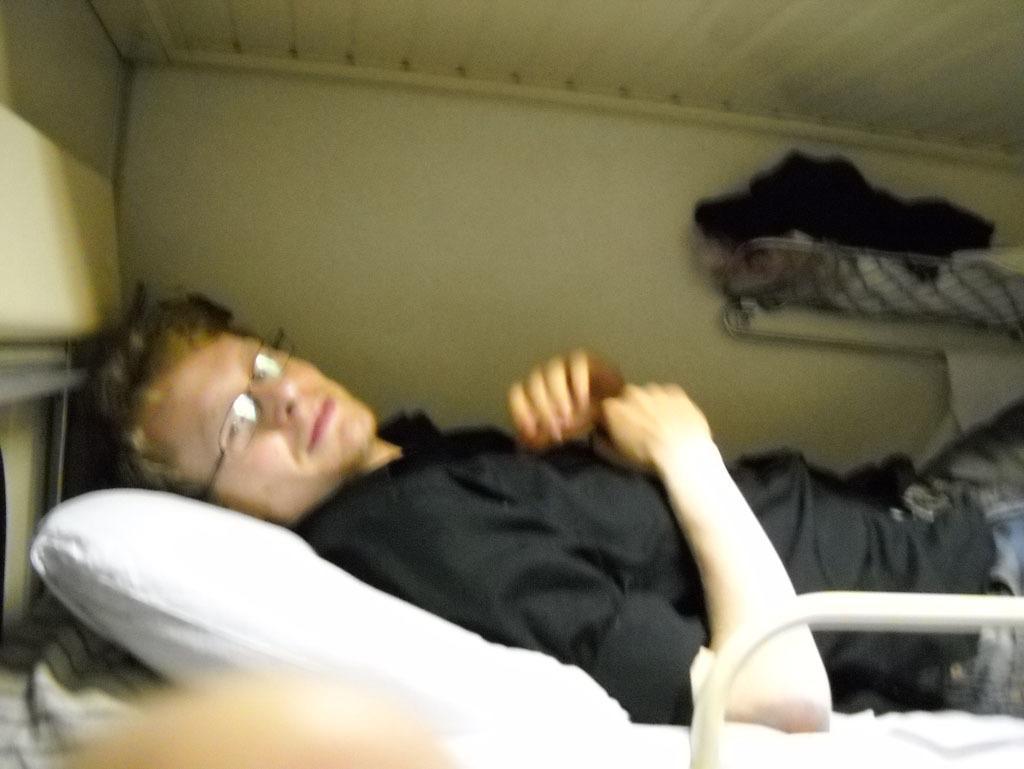Can you describe this image briefly? This is an image clicked inside the room. In this image I can see a man wearing black color shirt and laying on the bed. On the right side of the image I can see some clothes. 